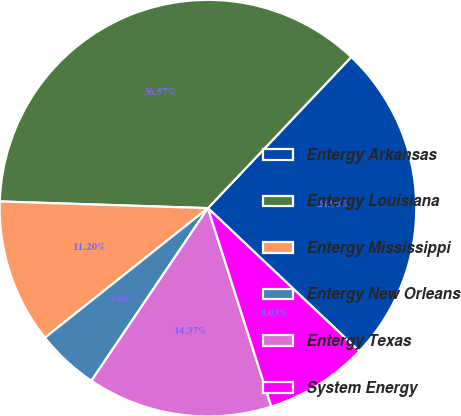Convert chart. <chart><loc_0><loc_0><loc_500><loc_500><pie_chart><fcel>Entergy Arkansas<fcel>Entergy Louisiana<fcel>Entergy Mississippi<fcel>Entergy New Orleans<fcel>Entergy Texas<fcel>System Energy<nl><fcel>24.98%<fcel>36.57%<fcel>11.2%<fcel>4.86%<fcel>14.37%<fcel>8.03%<nl></chart> 